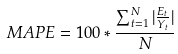Convert formula to latex. <formula><loc_0><loc_0><loc_500><loc_500>\ M A P E = 1 0 0 * { \frac { \sum _ { t = 1 } ^ { N } | { \frac { E _ { t } } { Y _ { t } } } | } { N } }</formula> 